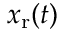<formula> <loc_0><loc_0><loc_500><loc_500>x _ { r } ( t )</formula> 